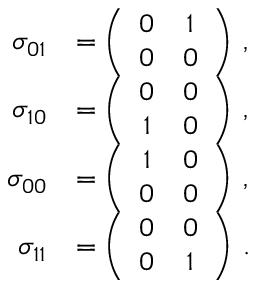Convert formula to latex. <formula><loc_0><loc_0><loc_500><loc_500>\begin{array} { r l } { \sigma _ { 0 1 } } & { = \left ( \begin{array} { c c } { 0 } & { 1 } \\ { 0 } & { 0 } \end{array} \right ) \, , } \\ { \sigma _ { 1 0 } } & { = \left ( \begin{array} { c c } { 0 } & { 0 } \\ { 1 } & { 0 } \end{array} \right ) \, , } \\ { \sigma _ { 0 0 } } & { = \left ( \begin{array} { c c } { 1 } & { 0 } \\ { 0 } & { 0 } \end{array} \right ) \, , } \\ { \sigma _ { 1 1 } } & { = \left ( \begin{array} { c c } { 0 } & { 0 } \\ { 0 } & { 1 } \end{array} \right ) \, . } \end{array}</formula> 